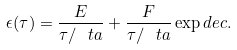Convert formula to latex. <formula><loc_0><loc_0><loc_500><loc_500>\epsilon ( \tau ) = \frac { E } { \tau / \ t a } + \frac { F } { \tau / \ t a } \exp d e c .</formula> 